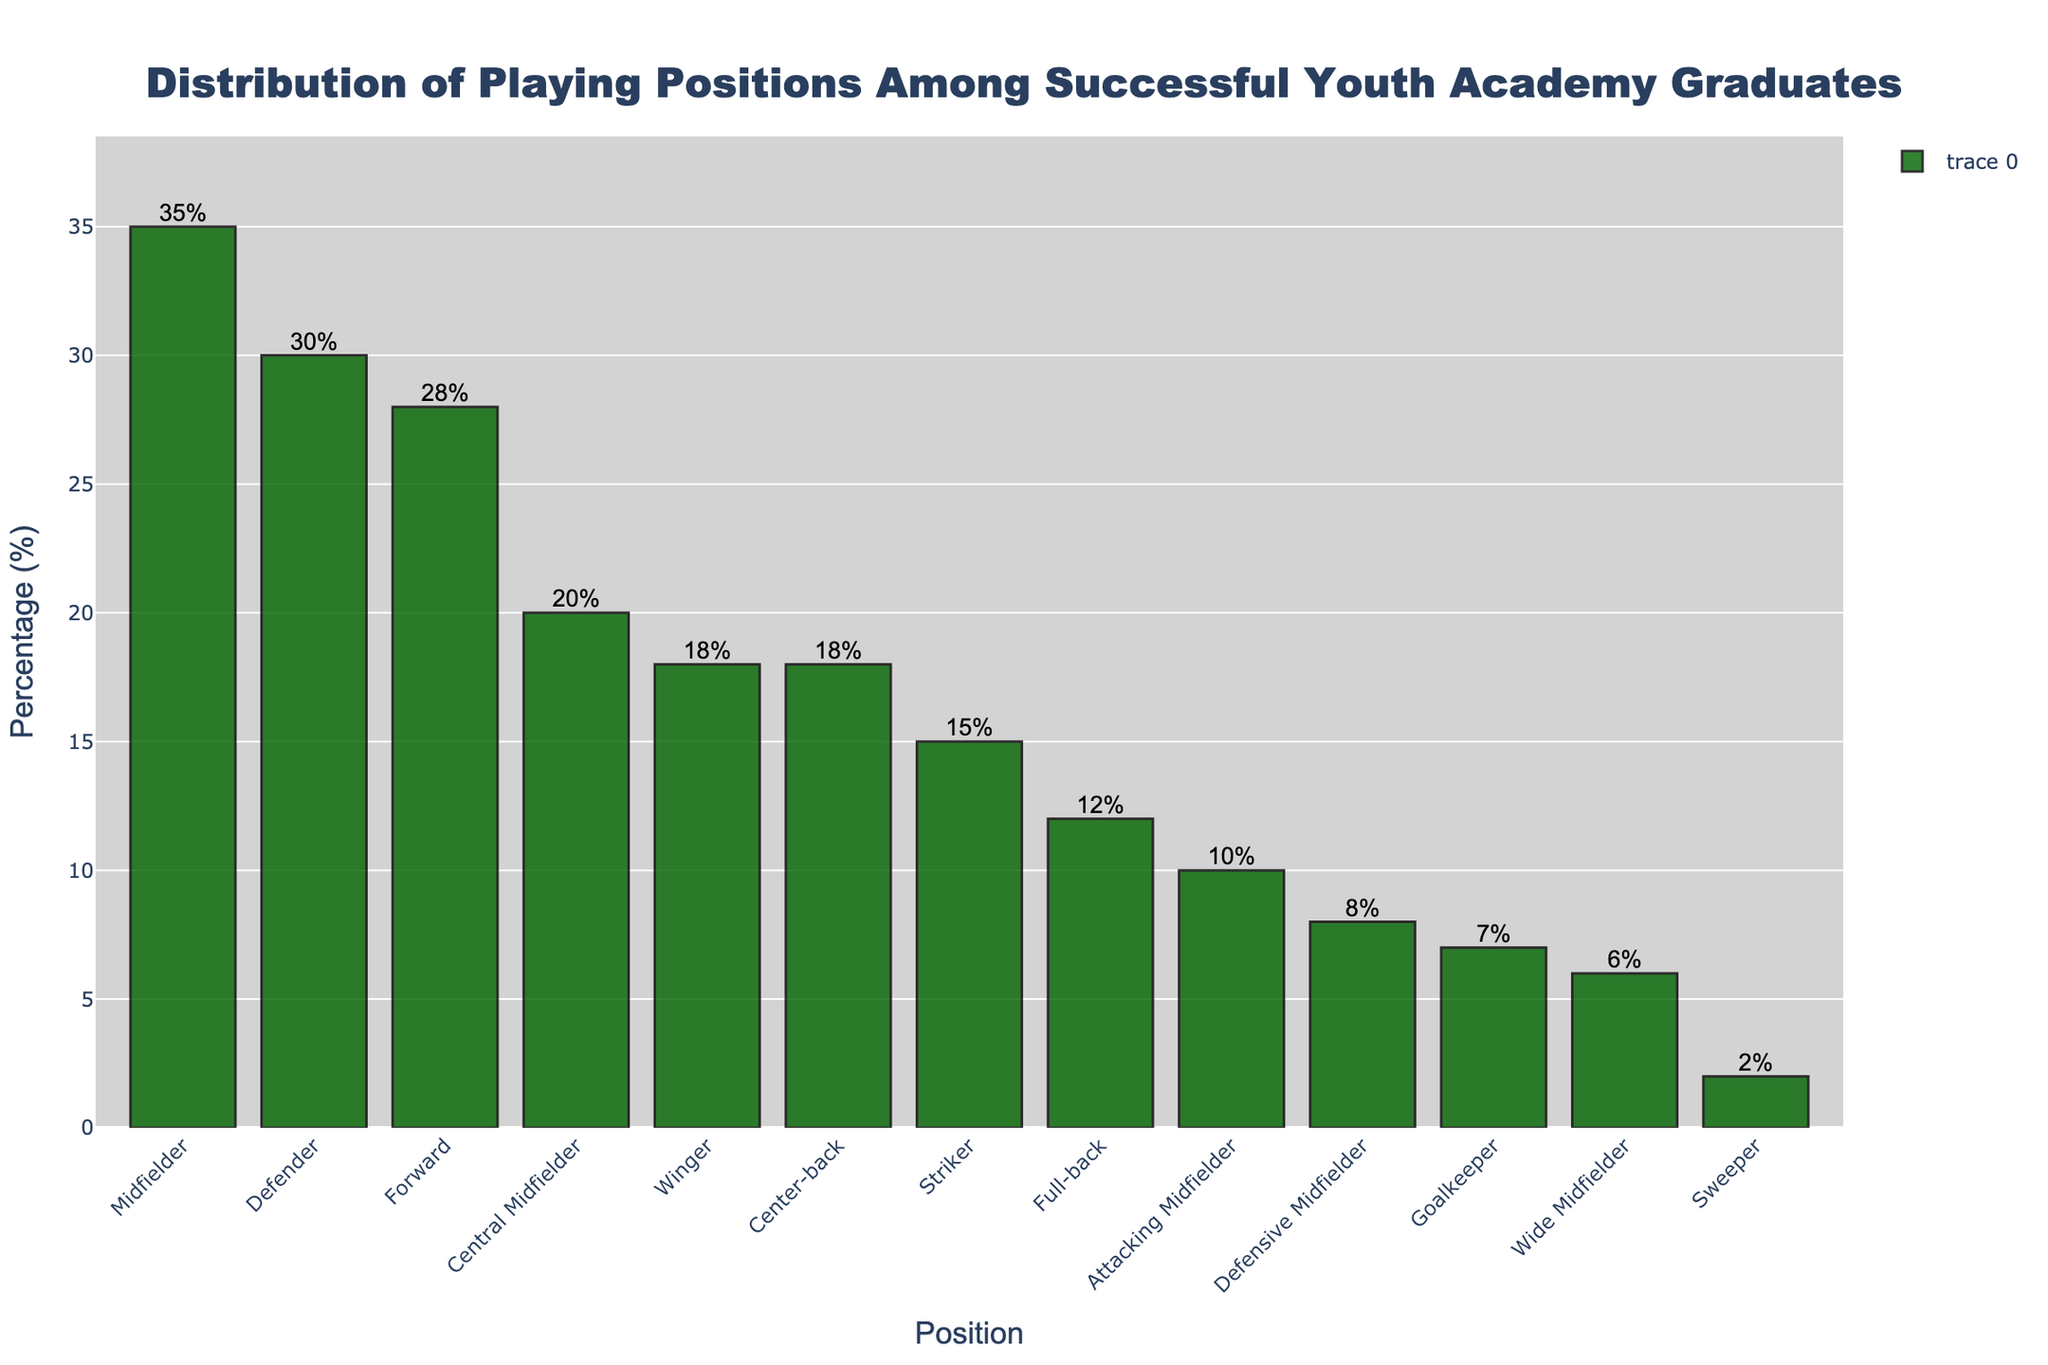Which position has the highest percentage among successful youth academy graduates? By inspecting the plot, identify the bar that reaches the highest point on the y-axis, representing the position with the highest percentage.
Answer: Midfielder Which position has the lowest percentage? Look for the shortest bar in the figure which indicates the lowest percentage among all positions listed.
Answer: Sweeper What is the combined percentage of Forward and Striker positions? Locate the percentages for Forward and Striker positions in the plot. Add them together (28% + 15%).
Answer: 43% Which has a higher percentage: Defenders or Goalkeepers? Compare the heights of the bars for Defenders and Goalkeepers. Defenders are at 30%, and Goalkeepers are at 7%.
Answer: Defenders What is the difference in percentage between Central Midfielders and Attacking Midfielders? Identify the bars corresponding to Central Midfielders and Attacking Midfielders. Subtract the percentage of Attacking Midfielders from Central Midfielders (20% - 10%).
Answer: 10% Are there more Full-backs or Wide Midfielders among successful graduates? Compare the heights of the bars for Full-backs and Wide Midfielders. Full-backs have 12%, while Wide Midfielders have 6%.
Answer: Full-backs How many positions have a percentage of 15% or higher? Count the number of bars in the chart that reach or exceed the 15% mark.
Answer: 4 What is the average percentage of Defenders, Goalkeepers, and Sweepers? Sum the percentages of Defenders, Goalkeepers, and Sweepers (30% + 7% + 2%) and divide by the number of positions (3).
Answer: 13% Which type of midfielder (Central, Attacking, Defensive, Wide) has the highest percentage? Compare the percentages of all four types of midfielders in the chart. Central Midfielder has 20%, Attacking Midfielder has 10%, Defensive Midfielder has 8%, and Wide Midfielder has 6%.
Answer: Central Midfielder What is the total percentage of all positions combined? Sum the percentages of all listed positions.
Answer: 199% 